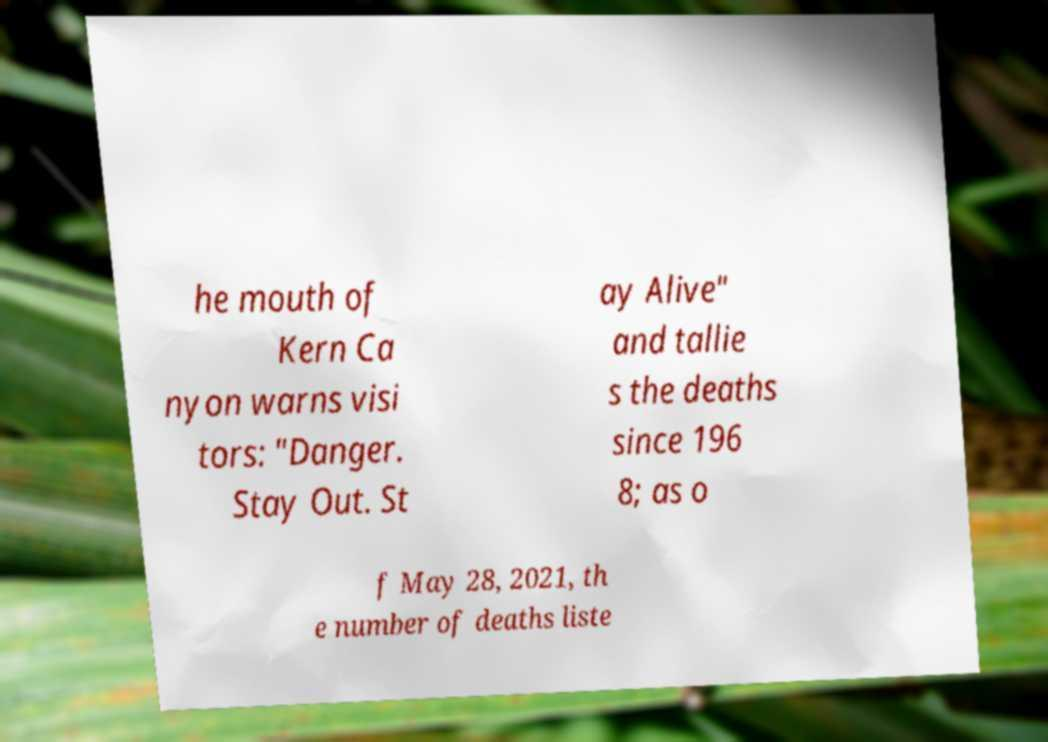There's text embedded in this image that I need extracted. Can you transcribe it verbatim? he mouth of Kern Ca nyon warns visi tors: "Danger. Stay Out. St ay Alive" and tallie s the deaths since 196 8; as o f May 28, 2021, th e number of deaths liste 